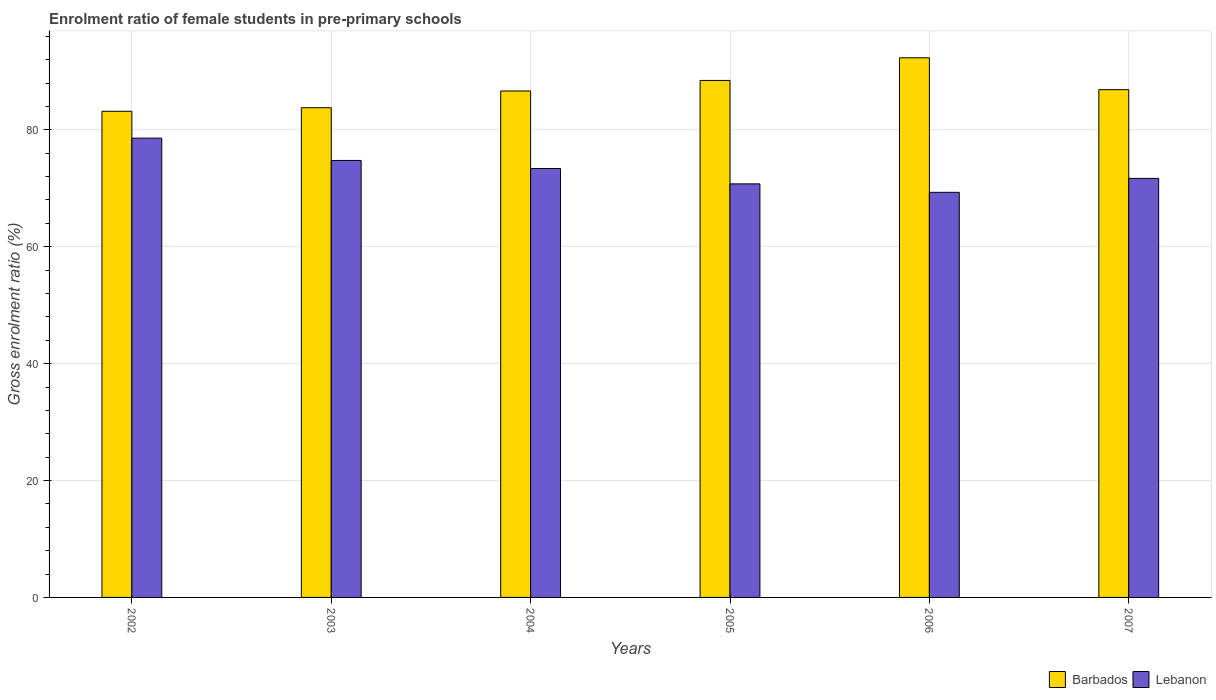How many different coloured bars are there?
Offer a terse response. 2. How many groups of bars are there?
Your response must be concise. 6. Are the number of bars per tick equal to the number of legend labels?
Make the answer very short. Yes. Are the number of bars on each tick of the X-axis equal?
Make the answer very short. Yes. How many bars are there on the 1st tick from the left?
Provide a short and direct response. 2. What is the enrolment ratio of female students in pre-primary schools in Lebanon in 2006?
Give a very brief answer. 69.31. Across all years, what is the maximum enrolment ratio of female students in pre-primary schools in Barbados?
Offer a terse response. 92.32. Across all years, what is the minimum enrolment ratio of female students in pre-primary schools in Lebanon?
Provide a short and direct response. 69.31. What is the total enrolment ratio of female students in pre-primary schools in Barbados in the graph?
Offer a very short reply. 521.23. What is the difference between the enrolment ratio of female students in pre-primary schools in Lebanon in 2002 and that in 2004?
Your response must be concise. 5.2. What is the difference between the enrolment ratio of female students in pre-primary schools in Barbados in 2005 and the enrolment ratio of female students in pre-primary schools in Lebanon in 2004?
Offer a terse response. 15.07. What is the average enrolment ratio of female students in pre-primary schools in Lebanon per year?
Your answer should be very brief. 73.08. In the year 2004, what is the difference between the enrolment ratio of female students in pre-primary schools in Barbados and enrolment ratio of female students in pre-primary schools in Lebanon?
Keep it short and to the point. 13.26. What is the ratio of the enrolment ratio of female students in pre-primary schools in Lebanon in 2004 to that in 2006?
Your response must be concise. 1.06. What is the difference between the highest and the second highest enrolment ratio of female students in pre-primary schools in Lebanon?
Ensure brevity in your answer.  3.82. What is the difference between the highest and the lowest enrolment ratio of female students in pre-primary schools in Barbados?
Make the answer very short. 9.15. In how many years, is the enrolment ratio of female students in pre-primary schools in Barbados greater than the average enrolment ratio of female students in pre-primary schools in Barbados taken over all years?
Your answer should be very brief. 2. What does the 2nd bar from the left in 2007 represents?
Make the answer very short. Lebanon. What does the 1st bar from the right in 2004 represents?
Offer a terse response. Lebanon. What is the difference between two consecutive major ticks on the Y-axis?
Offer a very short reply. 20. Are the values on the major ticks of Y-axis written in scientific E-notation?
Give a very brief answer. No. How many legend labels are there?
Provide a succinct answer. 2. What is the title of the graph?
Your answer should be very brief. Enrolment ratio of female students in pre-primary schools. Does "Chile" appear as one of the legend labels in the graph?
Keep it short and to the point. No. What is the Gross enrolment ratio (%) of Barbados in 2002?
Ensure brevity in your answer.  83.17. What is the Gross enrolment ratio (%) in Lebanon in 2002?
Ensure brevity in your answer.  78.58. What is the Gross enrolment ratio (%) in Barbados in 2003?
Your answer should be very brief. 83.78. What is the Gross enrolment ratio (%) of Lebanon in 2003?
Ensure brevity in your answer.  74.76. What is the Gross enrolment ratio (%) of Barbados in 2004?
Give a very brief answer. 86.64. What is the Gross enrolment ratio (%) of Lebanon in 2004?
Ensure brevity in your answer.  73.38. What is the Gross enrolment ratio (%) of Barbados in 2005?
Make the answer very short. 88.45. What is the Gross enrolment ratio (%) in Lebanon in 2005?
Provide a short and direct response. 70.75. What is the Gross enrolment ratio (%) of Barbados in 2006?
Your response must be concise. 92.32. What is the Gross enrolment ratio (%) in Lebanon in 2006?
Your response must be concise. 69.31. What is the Gross enrolment ratio (%) in Barbados in 2007?
Your response must be concise. 86.87. What is the Gross enrolment ratio (%) in Lebanon in 2007?
Provide a short and direct response. 71.69. Across all years, what is the maximum Gross enrolment ratio (%) in Barbados?
Your answer should be very brief. 92.32. Across all years, what is the maximum Gross enrolment ratio (%) in Lebanon?
Provide a short and direct response. 78.58. Across all years, what is the minimum Gross enrolment ratio (%) of Barbados?
Your answer should be very brief. 83.17. Across all years, what is the minimum Gross enrolment ratio (%) in Lebanon?
Provide a succinct answer. 69.31. What is the total Gross enrolment ratio (%) of Barbados in the graph?
Your answer should be compact. 521.23. What is the total Gross enrolment ratio (%) in Lebanon in the graph?
Your answer should be very brief. 438.48. What is the difference between the Gross enrolment ratio (%) of Barbados in 2002 and that in 2003?
Give a very brief answer. -0.61. What is the difference between the Gross enrolment ratio (%) in Lebanon in 2002 and that in 2003?
Make the answer very short. 3.82. What is the difference between the Gross enrolment ratio (%) in Barbados in 2002 and that in 2004?
Give a very brief answer. -3.47. What is the difference between the Gross enrolment ratio (%) in Lebanon in 2002 and that in 2004?
Offer a terse response. 5.2. What is the difference between the Gross enrolment ratio (%) of Barbados in 2002 and that in 2005?
Offer a terse response. -5.28. What is the difference between the Gross enrolment ratio (%) of Lebanon in 2002 and that in 2005?
Keep it short and to the point. 7.82. What is the difference between the Gross enrolment ratio (%) in Barbados in 2002 and that in 2006?
Provide a succinct answer. -9.15. What is the difference between the Gross enrolment ratio (%) of Lebanon in 2002 and that in 2006?
Keep it short and to the point. 9.27. What is the difference between the Gross enrolment ratio (%) in Barbados in 2002 and that in 2007?
Ensure brevity in your answer.  -3.7. What is the difference between the Gross enrolment ratio (%) of Lebanon in 2002 and that in 2007?
Provide a short and direct response. 6.89. What is the difference between the Gross enrolment ratio (%) in Barbados in 2003 and that in 2004?
Keep it short and to the point. -2.86. What is the difference between the Gross enrolment ratio (%) of Lebanon in 2003 and that in 2004?
Offer a terse response. 1.38. What is the difference between the Gross enrolment ratio (%) in Barbados in 2003 and that in 2005?
Give a very brief answer. -4.67. What is the difference between the Gross enrolment ratio (%) of Lebanon in 2003 and that in 2005?
Your answer should be compact. 4.01. What is the difference between the Gross enrolment ratio (%) of Barbados in 2003 and that in 2006?
Keep it short and to the point. -8.54. What is the difference between the Gross enrolment ratio (%) of Lebanon in 2003 and that in 2006?
Provide a succinct answer. 5.45. What is the difference between the Gross enrolment ratio (%) in Barbados in 2003 and that in 2007?
Offer a very short reply. -3.09. What is the difference between the Gross enrolment ratio (%) in Lebanon in 2003 and that in 2007?
Give a very brief answer. 3.07. What is the difference between the Gross enrolment ratio (%) of Barbados in 2004 and that in 2005?
Your answer should be compact. -1.81. What is the difference between the Gross enrolment ratio (%) of Lebanon in 2004 and that in 2005?
Your answer should be compact. 2.63. What is the difference between the Gross enrolment ratio (%) of Barbados in 2004 and that in 2006?
Keep it short and to the point. -5.68. What is the difference between the Gross enrolment ratio (%) in Lebanon in 2004 and that in 2006?
Keep it short and to the point. 4.07. What is the difference between the Gross enrolment ratio (%) of Barbados in 2004 and that in 2007?
Keep it short and to the point. -0.23. What is the difference between the Gross enrolment ratio (%) in Lebanon in 2004 and that in 2007?
Your response must be concise. 1.69. What is the difference between the Gross enrolment ratio (%) in Barbados in 2005 and that in 2006?
Ensure brevity in your answer.  -3.87. What is the difference between the Gross enrolment ratio (%) of Lebanon in 2005 and that in 2006?
Make the answer very short. 1.45. What is the difference between the Gross enrolment ratio (%) in Barbados in 2005 and that in 2007?
Provide a succinct answer. 1.58. What is the difference between the Gross enrolment ratio (%) in Lebanon in 2005 and that in 2007?
Make the answer very short. -0.94. What is the difference between the Gross enrolment ratio (%) in Barbados in 2006 and that in 2007?
Your answer should be very brief. 5.45. What is the difference between the Gross enrolment ratio (%) in Lebanon in 2006 and that in 2007?
Your answer should be compact. -2.39. What is the difference between the Gross enrolment ratio (%) in Barbados in 2002 and the Gross enrolment ratio (%) in Lebanon in 2003?
Ensure brevity in your answer.  8.41. What is the difference between the Gross enrolment ratio (%) in Barbados in 2002 and the Gross enrolment ratio (%) in Lebanon in 2004?
Your answer should be compact. 9.79. What is the difference between the Gross enrolment ratio (%) in Barbados in 2002 and the Gross enrolment ratio (%) in Lebanon in 2005?
Give a very brief answer. 12.42. What is the difference between the Gross enrolment ratio (%) of Barbados in 2002 and the Gross enrolment ratio (%) of Lebanon in 2006?
Ensure brevity in your answer.  13.86. What is the difference between the Gross enrolment ratio (%) in Barbados in 2002 and the Gross enrolment ratio (%) in Lebanon in 2007?
Offer a terse response. 11.48. What is the difference between the Gross enrolment ratio (%) of Barbados in 2003 and the Gross enrolment ratio (%) of Lebanon in 2004?
Keep it short and to the point. 10.4. What is the difference between the Gross enrolment ratio (%) of Barbados in 2003 and the Gross enrolment ratio (%) of Lebanon in 2005?
Provide a succinct answer. 13.03. What is the difference between the Gross enrolment ratio (%) of Barbados in 2003 and the Gross enrolment ratio (%) of Lebanon in 2006?
Provide a succinct answer. 14.47. What is the difference between the Gross enrolment ratio (%) in Barbados in 2003 and the Gross enrolment ratio (%) in Lebanon in 2007?
Make the answer very short. 12.09. What is the difference between the Gross enrolment ratio (%) of Barbados in 2004 and the Gross enrolment ratio (%) of Lebanon in 2005?
Your answer should be very brief. 15.89. What is the difference between the Gross enrolment ratio (%) of Barbados in 2004 and the Gross enrolment ratio (%) of Lebanon in 2006?
Provide a short and direct response. 17.33. What is the difference between the Gross enrolment ratio (%) of Barbados in 2004 and the Gross enrolment ratio (%) of Lebanon in 2007?
Provide a short and direct response. 14.95. What is the difference between the Gross enrolment ratio (%) of Barbados in 2005 and the Gross enrolment ratio (%) of Lebanon in 2006?
Ensure brevity in your answer.  19.14. What is the difference between the Gross enrolment ratio (%) in Barbados in 2005 and the Gross enrolment ratio (%) in Lebanon in 2007?
Offer a terse response. 16.76. What is the difference between the Gross enrolment ratio (%) in Barbados in 2006 and the Gross enrolment ratio (%) in Lebanon in 2007?
Give a very brief answer. 20.63. What is the average Gross enrolment ratio (%) in Barbados per year?
Your answer should be compact. 86.87. What is the average Gross enrolment ratio (%) in Lebanon per year?
Your response must be concise. 73.08. In the year 2002, what is the difference between the Gross enrolment ratio (%) of Barbados and Gross enrolment ratio (%) of Lebanon?
Make the answer very short. 4.59. In the year 2003, what is the difference between the Gross enrolment ratio (%) of Barbados and Gross enrolment ratio (%) of Lebanon?
Your answer should be very brief. 9.02. In the year 2004, what is the difference between the Gross enrolment ratio (%) in Barbados and Gross enrolment ratio (%) in Lebanon?
Your response must be concise. 13.26. In the year 2005, what is the difference between the Gross enrolment ratio (%) of Barbados and Gross enrolment ratio (%) of Lebanon?
Provide a succinct answer. 17.7. In the year 2006, what is the difference between the Gross enrolment ratio (%) in Barbados and Gross enrolment ratio (%) in Lebanon?
Your answer should be very brief. 23.01. In the year 2007, what is the difference between the Gross enrolment ratio (%) in Barbados and Gross enrolment ratio (%) in Lebanon?
Your answer should be compact. 15.17. What is the ratio of the Gross enrolment ratio (%) of Lebanon in 2002 to that in 2003?
Your answer should be very brief. 1.05. What is the ratio of the Gross enrolment ratio (%) of Barbados in 2002 to that in 2004?
Your answer should be compact. 0.96. What is the ratio of the Gross enrolment ratio (%) in Lebanon in 2002 to that in 2004?
Make the answer very short. 1.07. What is the ratio of the Gross enrolment ratio (%) of Barbados in 2002 to that in 2005?
Offer a terse response. 0.94. What is the ratio of the Gross enrolment ratio (%) in Lebanon in 2002 to that in 2005?
Your answer should be compact. 1.11. What is the ratio of the Gross enrolment ratio (%) of Barbados in 2002 to that in 2006?
Your response must be concise. 0.9. What is the ratio of the Gross enrolment ratio (%) in Lebanon in 2002 to that in 2006?
Your answer should be compact. 1.13. What is the ratio of the Gross enrolment ratio (%) in Barbados in 2002 to that in 2007?
Offer a terse response. 0.96. What is the ratio of the Gross enrolment ratio (%) in Lebanon in 2002 to that in 2007?
Make the answer very short. 1.1. What is the ratio of the Gross enrolment ratio (%) of Barbados in 2003 to that in 2004?
Your answer should be compact. 0.97. What is the ratio of the Gross enrolment ratio (%) of Lebanon in 2003 to that in 2004?
Provide a short and direct response. 1.02. What is the ratio of the Gross enrolment ratio (%) of Barbados in 2003 to that in 2005?
Make the answer very short. 0.95. What is the ratio of the Gross enrolment ratio (%) in Lebanon in 2003 to that in 2005?
Your answer should be compact. 1.06. What is the ratio of the Gross enrolment ratio (%) in Barbados in 2003 to that in 2006?
Offer a very short reply. 0.91. What is the ratio of the Gross enrolment ratio (%) in Lebanon in 2003 to that in 2006?
Give a very brief answer. 1.08. What is the ratio of the Gross enrolment ratio (%) in Barbados in 2003 to that in 2007?
Your response must be concise. 0.96. What is the ratio of the Gross enrolment ratio (%) of Lebanon in 2003 to that in 2007?
Ensure brevity in your answer.  1.04. What is the ratio of the Gross enrolment ratio (%) in Barbados in 2004 to that in 2005?
Provide a short and direct response. 0.98. What is the ratio of the Gross enrolment ratio (%) of Lebanon in 2004 to that in 2005?
Your answer should be compact. 1.04. What is the ratio of the Gross enrolment ratio (%) in Barbados in 2004 to that in 2006?
Offer a very short reply. 0.94. What is the ratio of the Gross enrolment ratio (%) of Lebanon in 2004 to that in 2006?
Ensure brevity in your answer.  1.06. What is the ratio of the Gross enrolment ratio (%) in Barbados in 2004 to that in 2007?
Keep it short and to the point. 1. What is the ratio of the Gross enrolment ratio (%) in Lebanon in 2004 to that in 2007?
Give a very brief answer. 1.02. What is the ratio of the Gross enrolment ratio (%) of Barbados in 2005 to that in 2006?
Provide a succinct answer. 0.96. What is the ratio of the Gross enrolment ratio (%) of Lebanon in 2005 to that in 2006?
Offer a terse response. 1.02. What is the ratio of the Gross enrolment ratio (%) of Barbados in 2005 to that in 2007?
Provide a succinct answer. 1.02. What is the ratio of the Gross enrolment ratio (%) in Lebanon in 2005 to that in 2007?
Make the answer very short. 0.99. What is the ratio of the Gross enrolment ratio (%) of Barbados in 2006 to that in 2007?
Make the answer very short. 1.06. What is the ratio of the Gross enrolment ratio (%) in Lebanon in 2006 to that in 2007?
Ensure brevity in your answer.  0.97. What is the difference between the highest and the second highest Gross enrolment ratio (%) of Barbados?
Your response must be concise. 3.87. What is the difference between the highest and the second highest Gross enrolment ratio (%) in Lebanon?
Your answer should be very brief. 3.82. What is the difference between the highest and the lowest Gross enrolment ratio (%) of Barbados?
Provide a short and direct response. 9.15. What is the difference between the highest and the lowest Gross enrolment ratio (%) in Lebanon?
Offer a terse response. 9.27. 